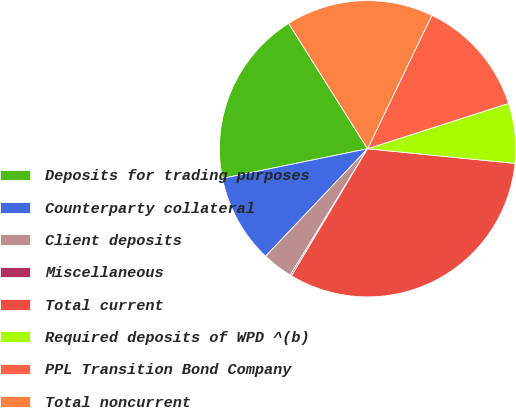<chart> <loc_0><loc_0><loc_500><loc_500><pie_chart><fcel>Deposits for trading purposes<fcel>Counterparty collateral<fcel>Client deposits<fcel>Miscellaneous<fcel>Total current<fcel>Required deposits of WPD ^(b)<fcel>PPL Transition Bond Company<fcel>Total noncurrent<nl><fcel>19.27%<fcel>9.71%<fcel>3.34%<fcel>0.16%<fcel>32.01%<fcel>6.53%<fcel>12.9%<fcel>16.08%<nl></chart> 